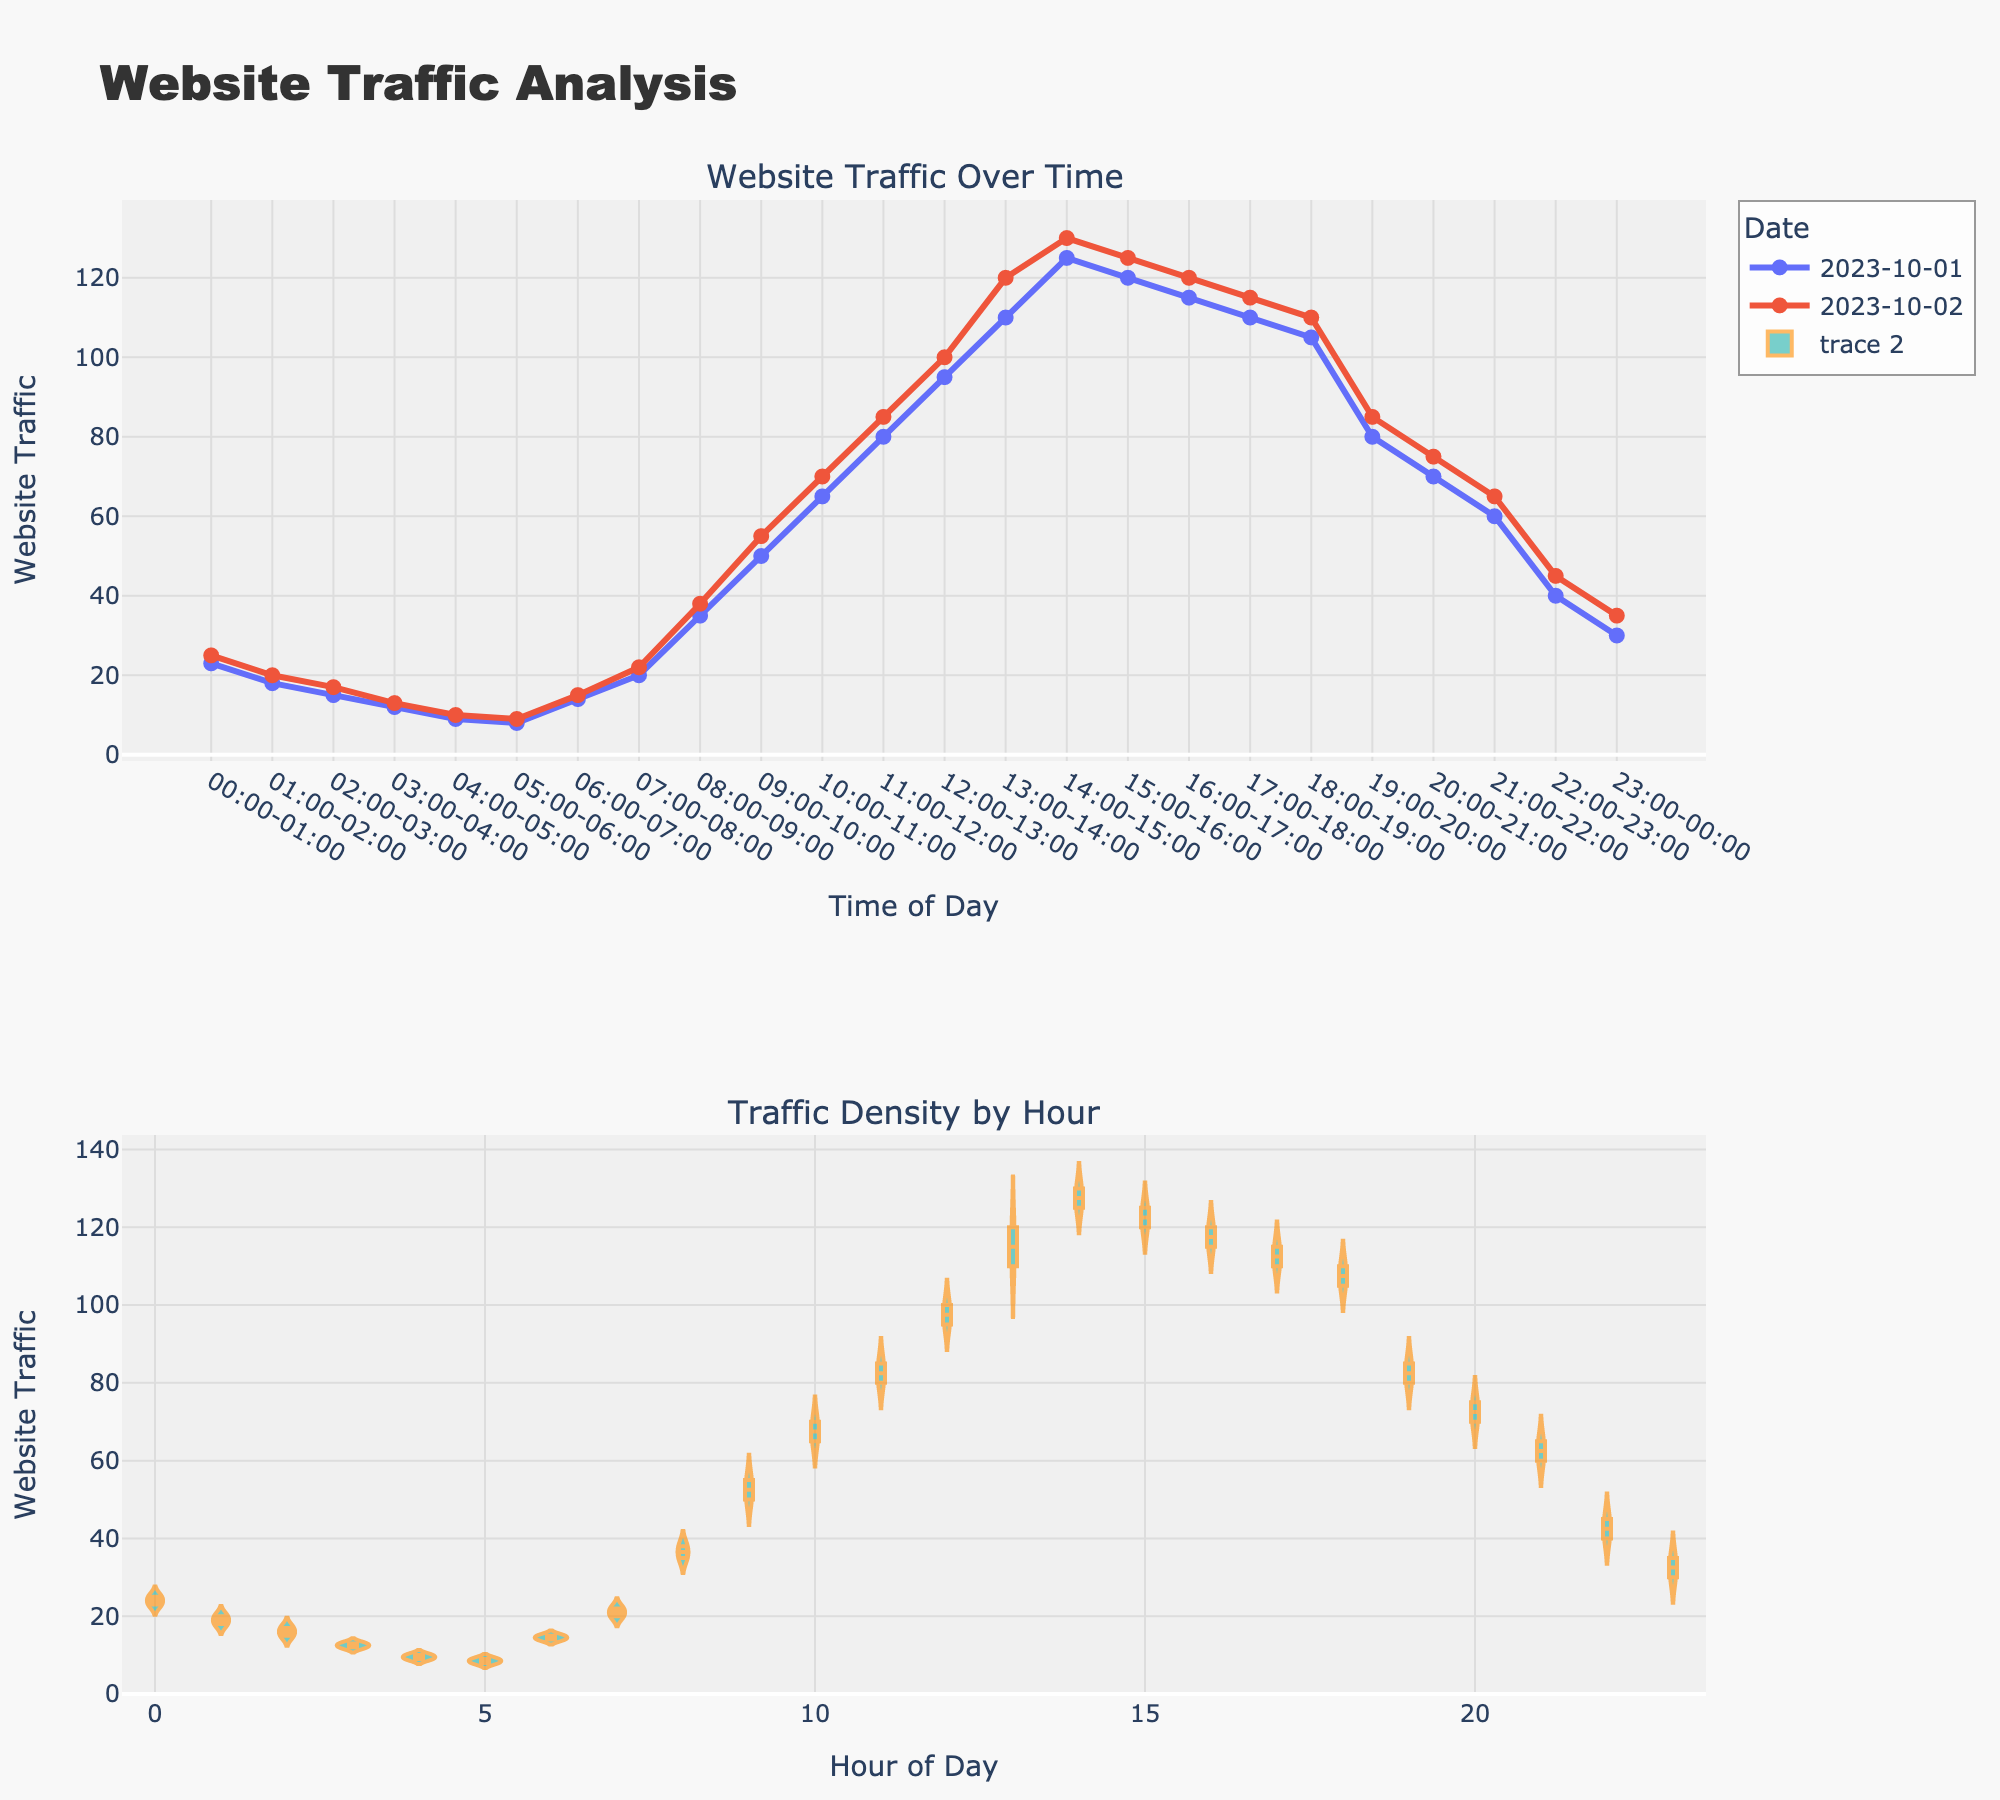what is the title of the figure? The title of the figure is prominently displayed at the top of the plot.
Answer: Website Traffic Analysis during which hour is website traffic the highest on October 1st? The highest website traffic on October 1st can be found by looking at the peak value in the line plot for October 1st.
Answer: 14:00-15:00 compare the website traffic at 10:00-11:00 across both dates. which day has more traffic? To find this, compare the data points for 10:00-11:00 on both October 1st and October 2nd in the line plot.
Answer: October 2nd what is the general trend observed in the website traffic over time on October 2nd? The line plot for October 2nd shows the traffic rising from early morning, peaking in the afternoon, and then gradually decreasing.
Answer: Increasing, then decreasing which hour of the day consistently experiences the lowest website traffic? The hour with the lowest traffic can be seen in the density plot, where the lowest violin width near the baseline indicates the hour.
Answer: 05:00-06:00 at approximately what time does the traffic start to decline after reaching its peak? Observing the peak period in the line plot and when it starts trending downwards gives this time.
Answer: 15:00-16:00 how many distinct peaks are there on the website traffic line plot for October 1st? Counting the number of high points or visible peaks in the line plot for October 1st determines this.
Answer: 1 what is the interquartile range (IQR) of website traffic densities around 12:00-14:00? The IQR is found by looking at the range between the first and third quartiles in the violin plot for the highlighted hours.
Answer: 30 compare the shape of the density plots for morning (06:00-12:00) and evening (18:00-00:00). which period has more variation in website traffic? By comparing the width of the violin plots for the two time periods, the period with the wider plot signifies more variation.
Answer: Morning (06:00-12:00) describe the traffic pattern in the late evening (21:00-23:00) based on the density plot. Observing the shape and spread of the violin plot for the late evening hours. These plots show the frequencies and variation of website traffic.
Answer: Steady decrease 